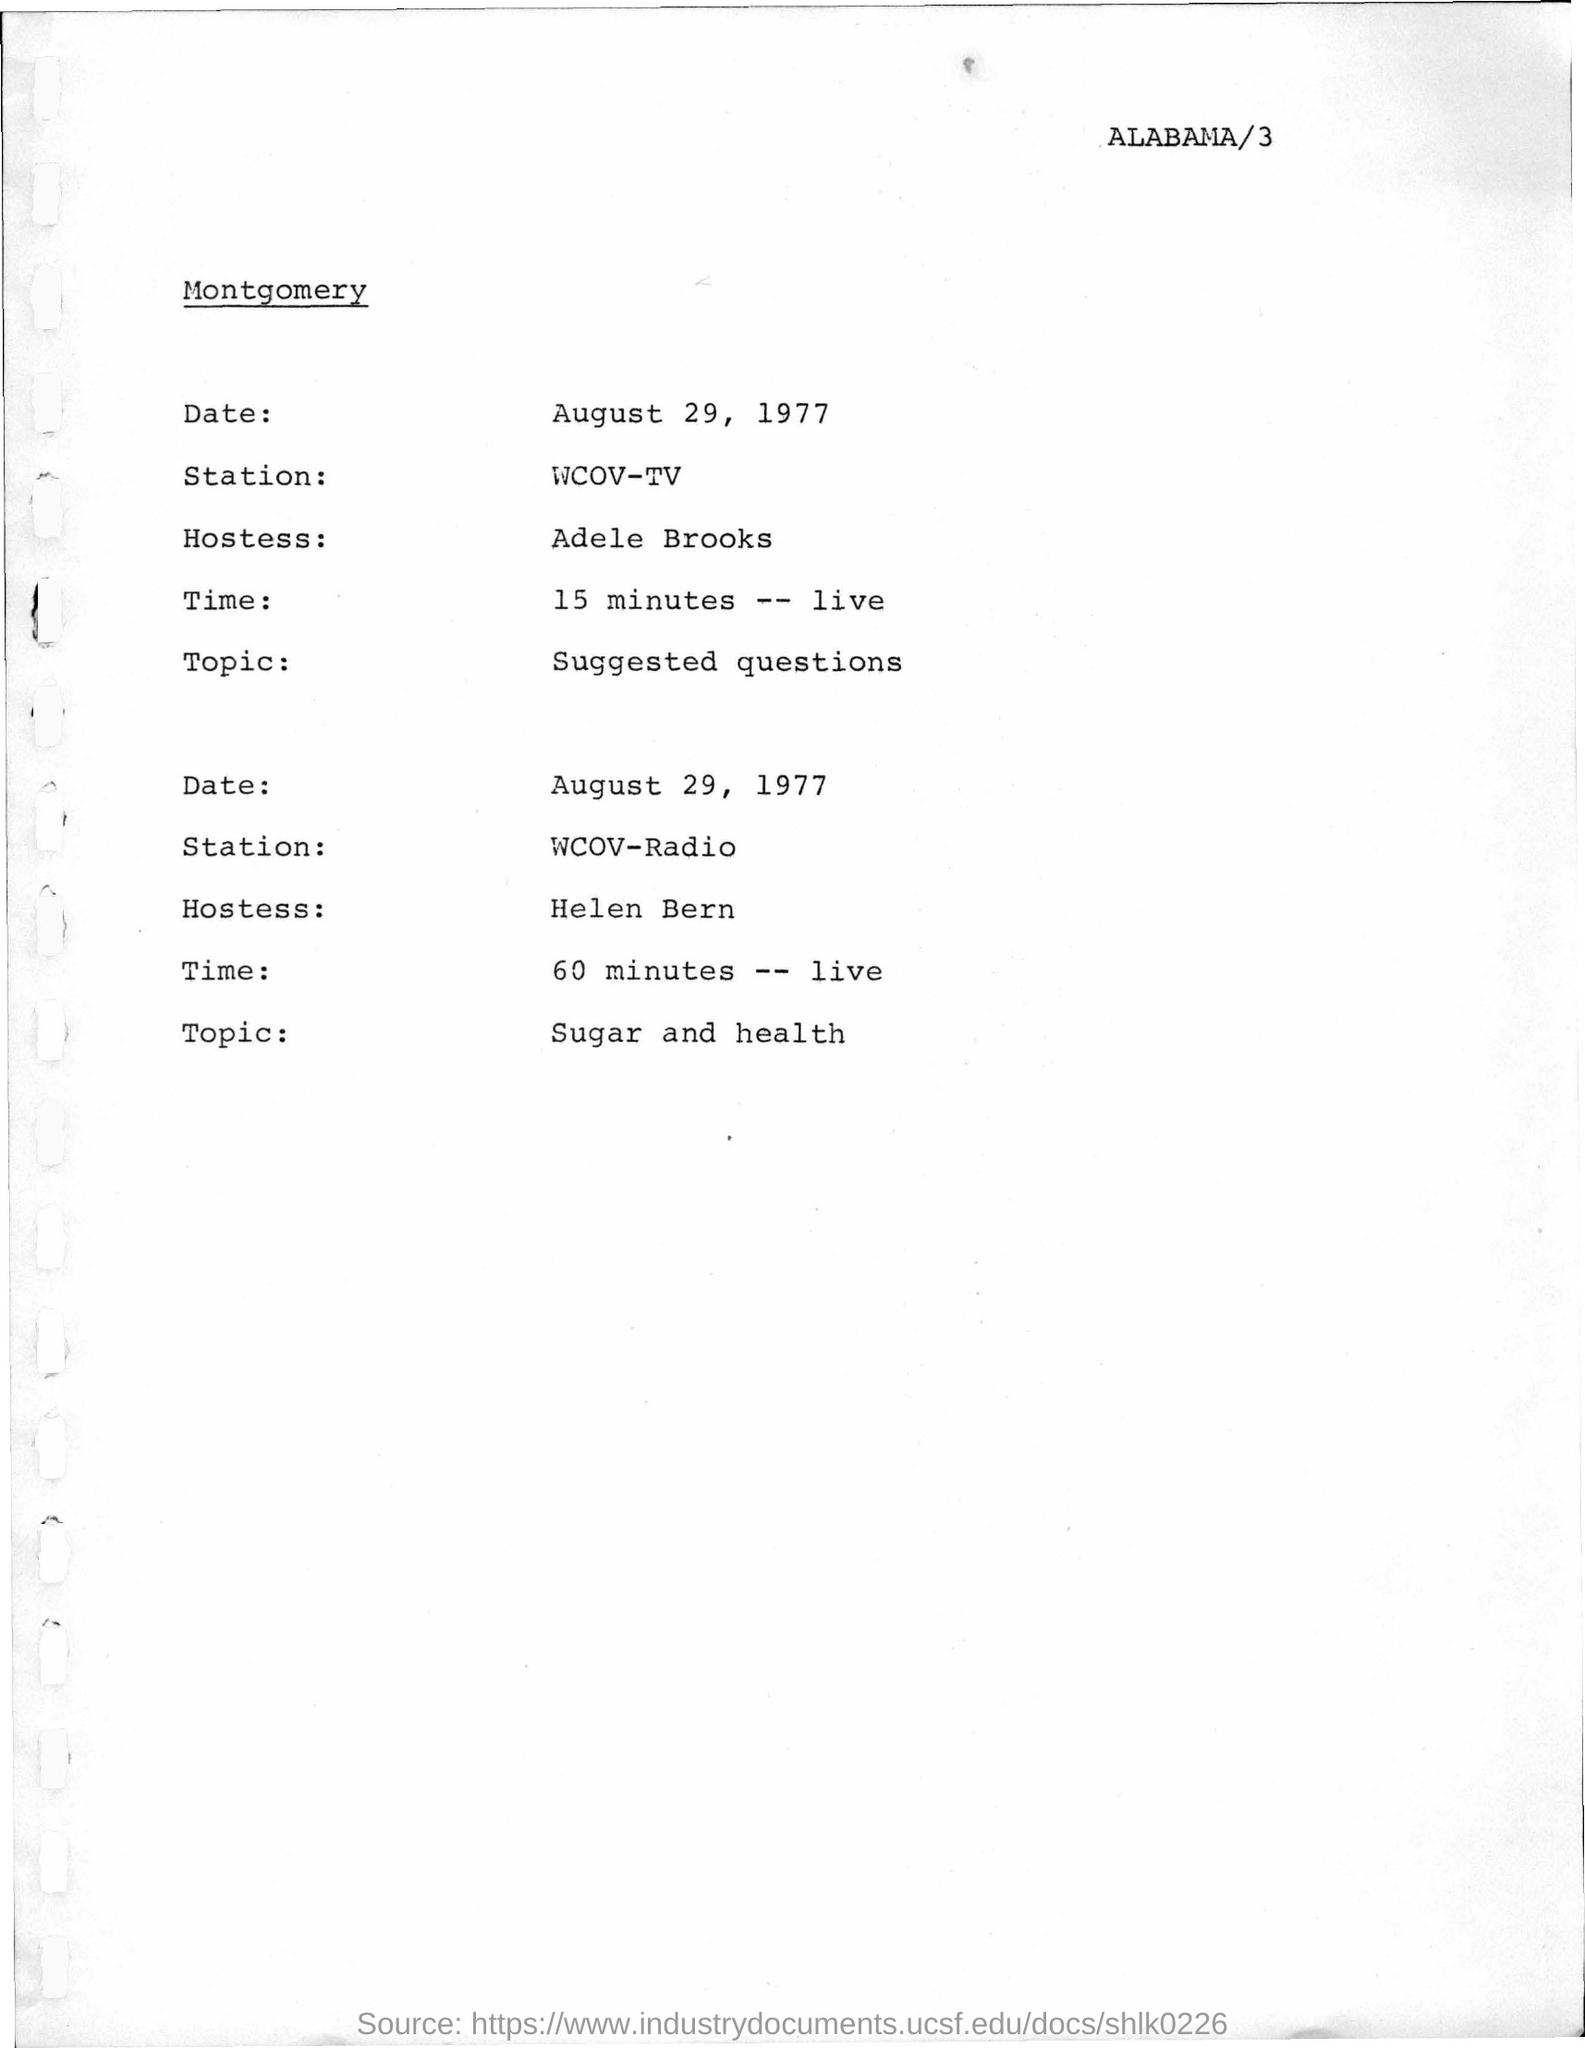Identify some key points in this picture. The topic mentioned in the second para is sugar and health. The date mentioned on the given page is August 29, 1977. 